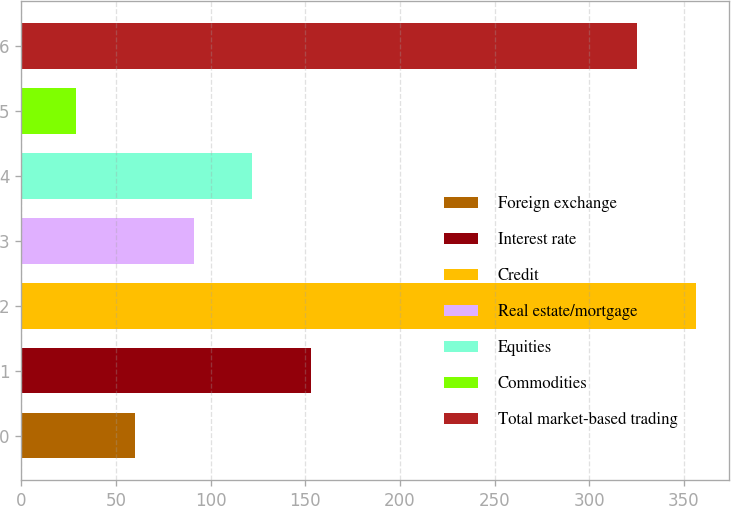Convert chart. <chart><loc_0><loc_0><loc_500><loc_500><bar_chart><fcel>Foreign exchange<fcel>Interest rate<fcel>Credit<fcel>Real estate/mortgage<fcel>Equities<fcel>Commodities<fcel>Total market-based trading<nl><fcel>60.06<fcel>152.94<fcel>356.16<fcel>91.02<fcel>121.98<fcel>29.1<fcel>325.2<nl></chart> 